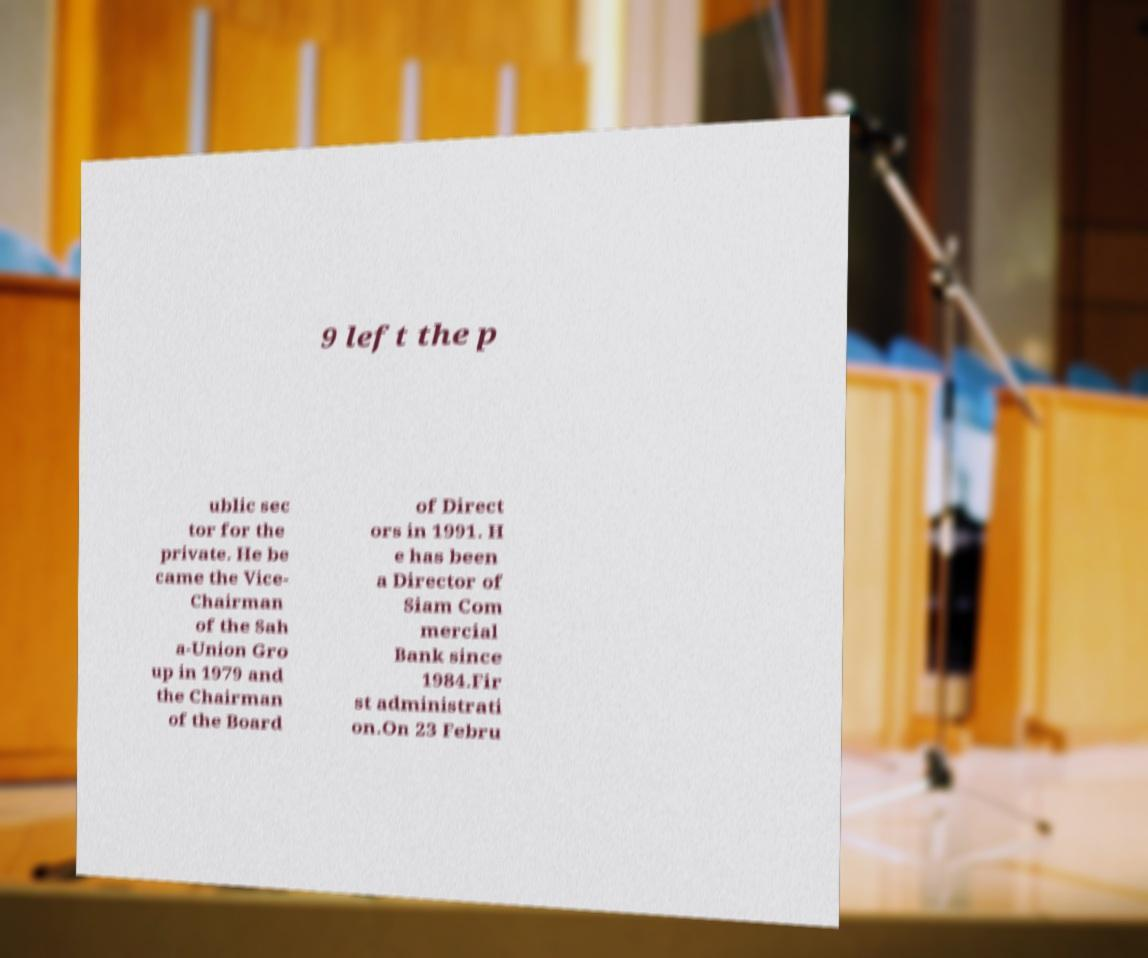There's text embedded in this image that I need extracted. Can you transcribe it verbatim? 9 left the p ublic sec tor for the private. He be came the Vice- Chairman of the Sah a-Union Gro up in 1979 and the Chairman of the Board of Direct ors in 1991. H e has been a Director of Siam Com mercial Bank since 1984.Fir st administrati on.On 23 Febru 